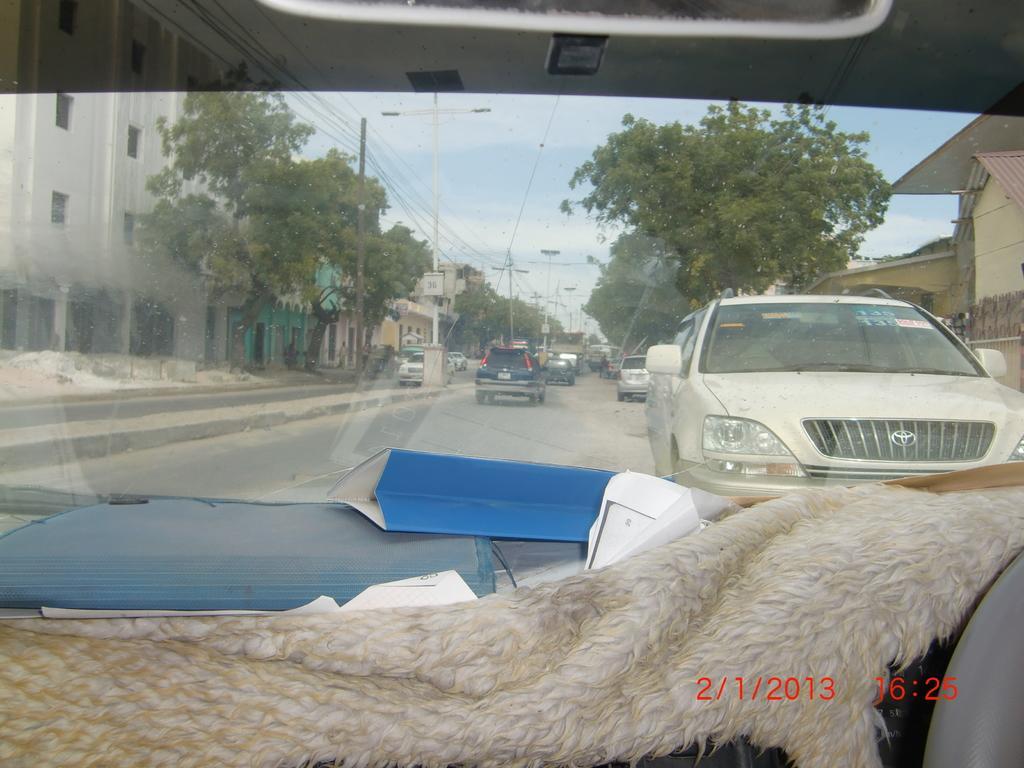Describe this image in one or two sentences. In this image we can see motor vehicles on the road, buildings, trees, electric poles, electric cables, street poles, street lights and sky with clouds through a motor vehicle's window. 